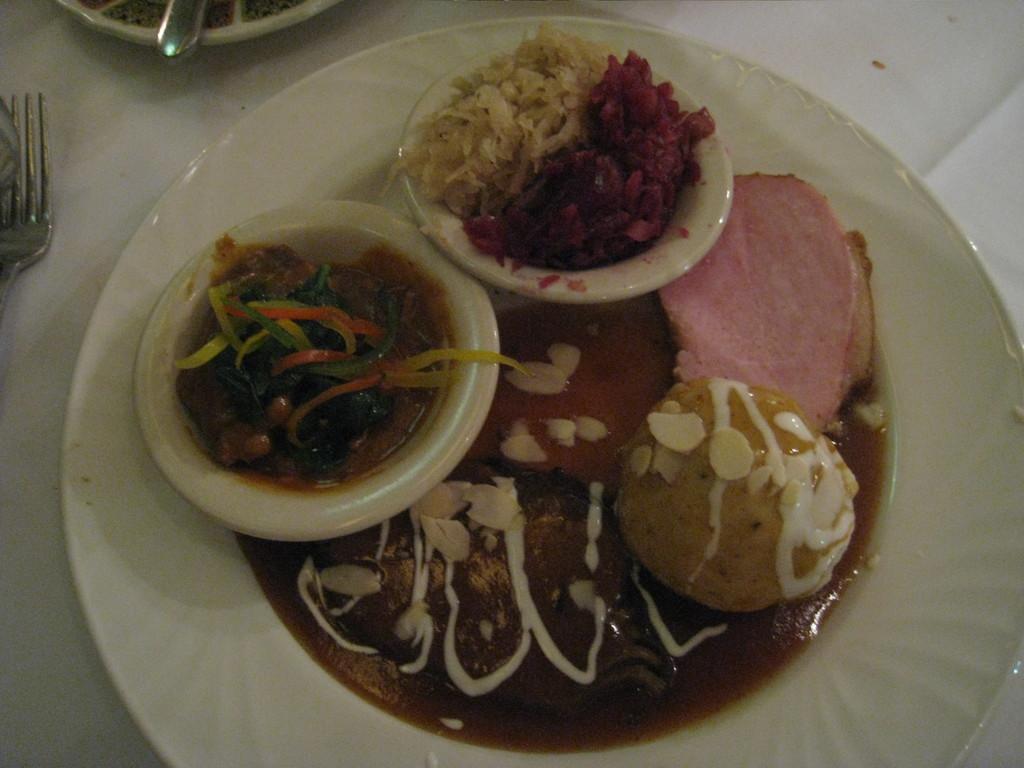Can you describe this image briefly? On the table there is a plate, fork, bowls, and food. 